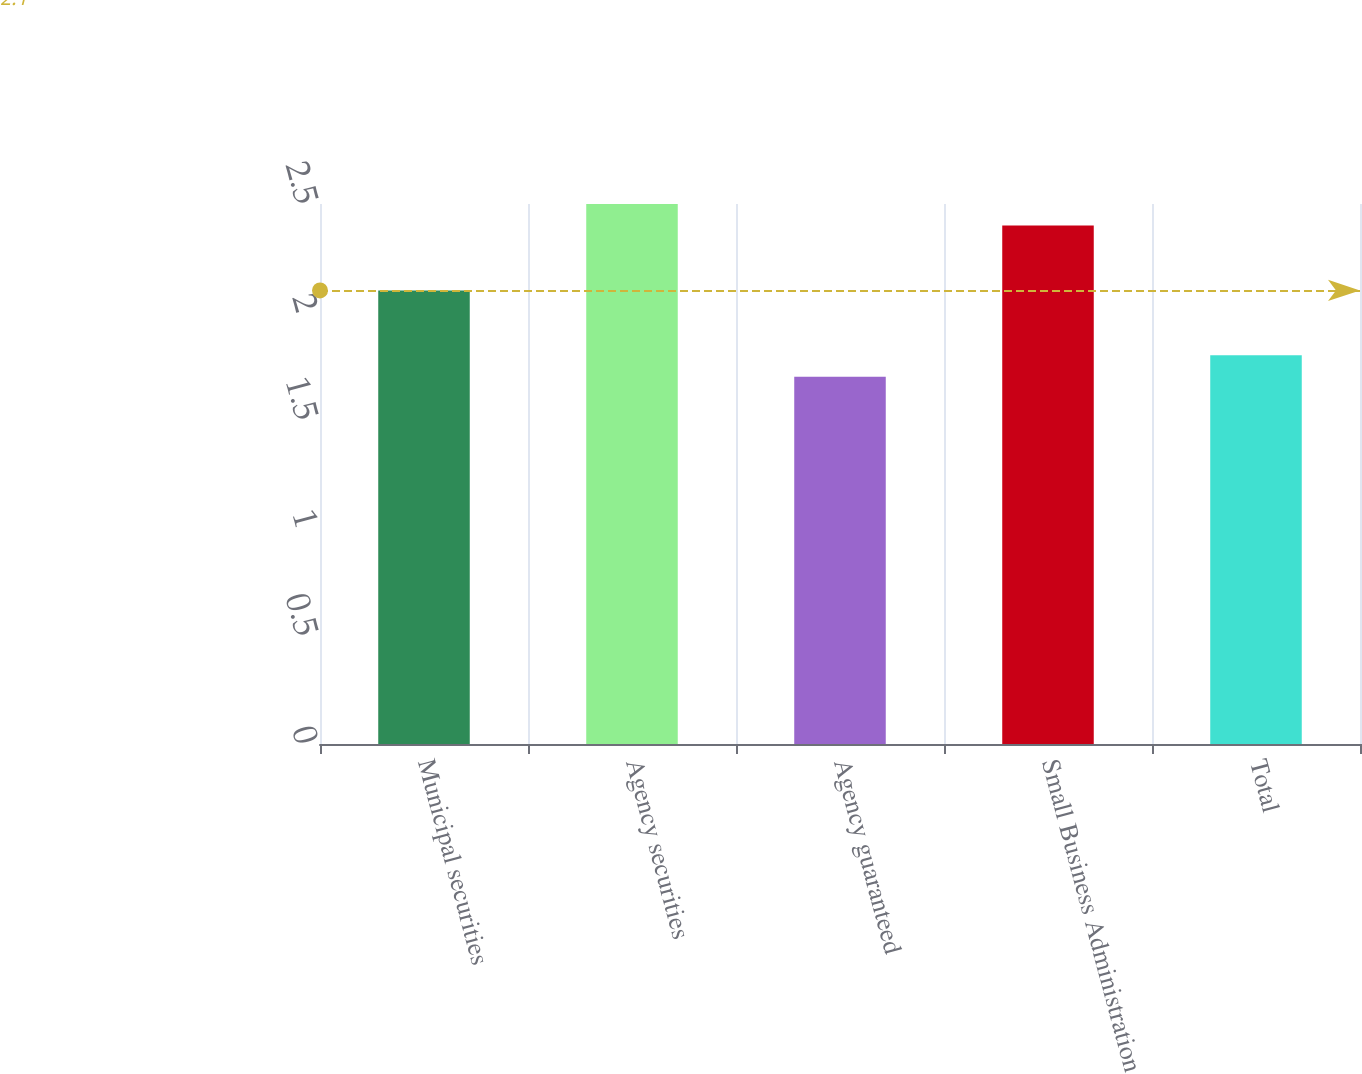Convert chart to OTSL. <chart><loc_0><loc_0><loc_500><loc_500><bar_chart><fcel>Municipal securities<fcel>Agency securities<fcel>Agency guaranteed<fcel>Small Business Administration<fcel>Total<nl><fcel>2.1<fcel>2.5<fcel>1.7<fcel>2.4<fcel>1.8<nl></chart> 